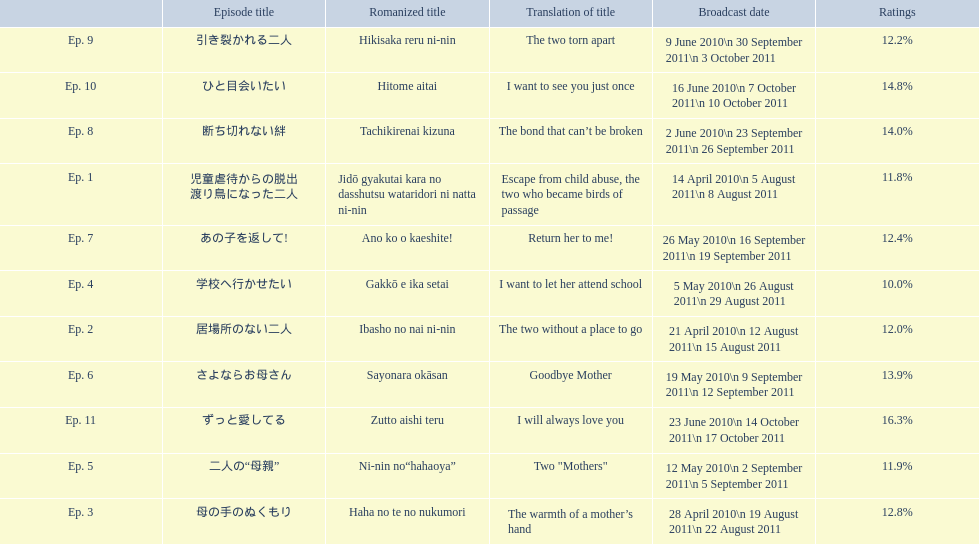How many total episodes are there? Ep. 1, Ep. 2, Ep. 3, Ep. 4, Ep. 5, Ep. 6, Ep. 7, Ep. 8, Ep. 9, Ep. 10, Ep. 11. Of those episodes, which one has the title of the bond that can't be broken? Ep. 8. What was the ratings percentage for that episode? 14.0%. 